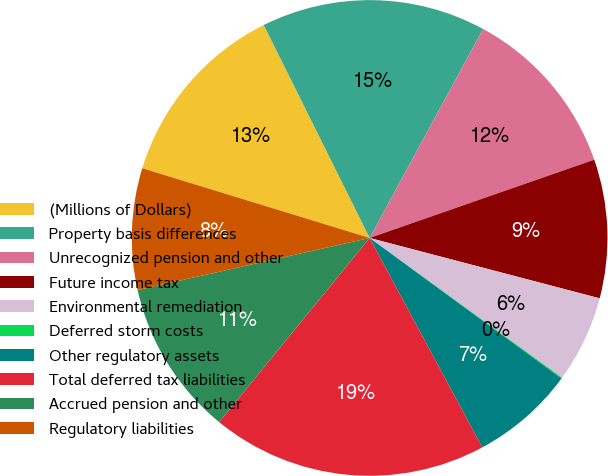Convert chart to OTSL. <chart><loc_0><loc_0><loc_500><loc_500><pie_chart><fcel>(Millions of Dollars)<fcel>Property basis differences<fcel>Unrecognized pension and other<fcel>Future income tax<fcel>Environmental remediation<fcel>Deferred storm costs<fcel>Other regulatory assets<fcel>Total deferred tax liabilities<fcel>Accrued pension and other<fcel>Regulatory liabilities<nl><fcel>12.92%<fcel>15.26%<fcel>11.75%<fcel>9.42%<fcel>5.91%<fcel>0.07%<fcel>7.08%<fcel>18.76%<fcel>10.58%<fcel>8.25%<nl></chart> 